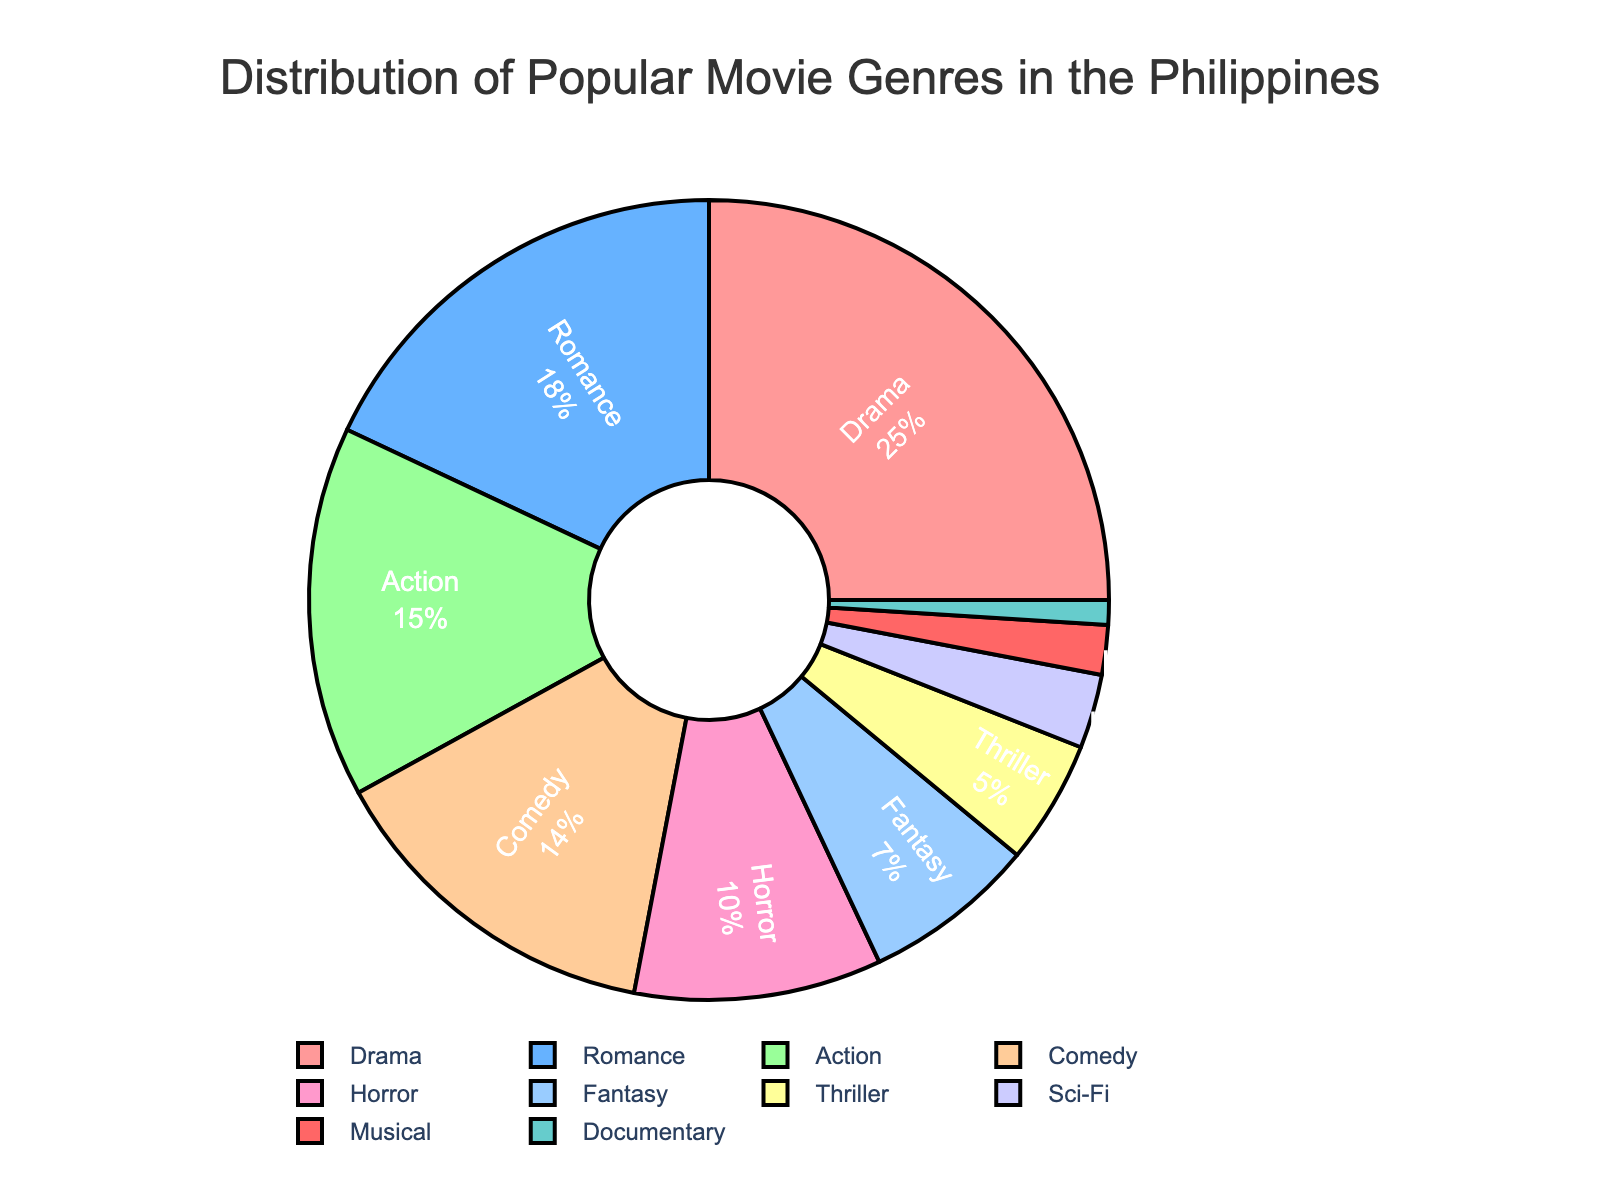What genre has the highest percentage? The genre with the highest percentage is identified as the one corresponding to the largest slice of the pie chart. In this case, "Drama" occupies the largest portion.
Answer: Drama Which two genres together make up more than one-third of the total percentage? The combined percentage of two genres should be greater than 33.33%. The two largest percentages are Drama (25%) and Romance (18%). Their sum, 25% + 18%, is 43%, which is more than one-third.
Answer: Drama and Romance How much larger is the percentage of Drama compared to Horror? Subtract the percentage of Horror (10%) from the percentage of Drama (25%). 25% - 10% = 15%.
Answer: 15% Which genre has the smallest percentage? The genre with the smallest percentage corresponds to the smallest slice of the pie chart. Here, "Documentary" has the smallest portion, which is 1%.
Answer: Documentary What is the percentage difference between Action and Comedy? Subtract the percentage of Comedy (14%) from the percentage of Action (15%). 15% - 14% = 1%.
Answer: 1% What are the colors used for the top three genres by percentage? The colors for the top three genres, which are Drama (25%), Romance (18%), and Action (15%), are analyzed based on their corresponding pie chart slices. Drama is shown in red, Romance in blue, and Action in green.
Answer: Red, Blue, Green How does the percentage of Fantasy compare to that of Thriller? Compare the percentages directly: Fantasy is 7% and Thriller is 5%. 7% is greater than 5%, so Fantasy is larger.
Answer: Fantasy is larger If the percentages of genre Horror and Sci-Fi are combined, what is their total? Add the percentages of Horror (10%) and Sci-Fi (3%). 10% + 3% = 13%.
Answer: 13% Which genres collectively make up half of the total percentage? Identify genres until their total percentage equals 50%. Drama (25%) + Romance (18%) + Action (15%) sums to 58%, which is more than half, so we need fewer than all three. Drama (25%) + Romance (18%) = 43%. Including the next one, Action, which adds another 15%, makes it 43% + 15% = 58%. Therefore, Drama and Romance summed alone ≠ 50%, but Drama + Romance + Action = 58, hence we can find subsets/extractions here, but as stated Drama = 25% + Romance = 18% gets most particularly closest but unless additive further than following script errors simplify Drama + Romance is respectively
Answer: Drama, Romance + (Action, etc.) Is the total percentage of Comedy, Horror, and Documentary more than 20%? Add the percentages of Comedy (14%), Horror (10%), and Documentary (1%). 14% + 10% + 1% = 25%, which is more than 20%.
Answer: Yes 